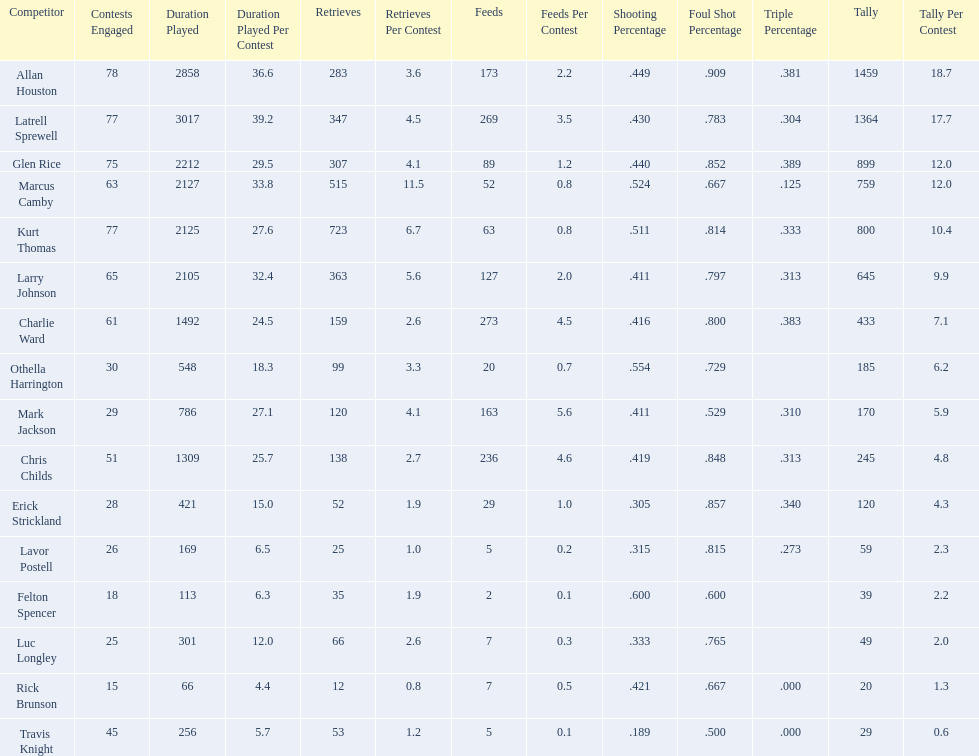How many players had a field goal percentage greater than .500? 4. 